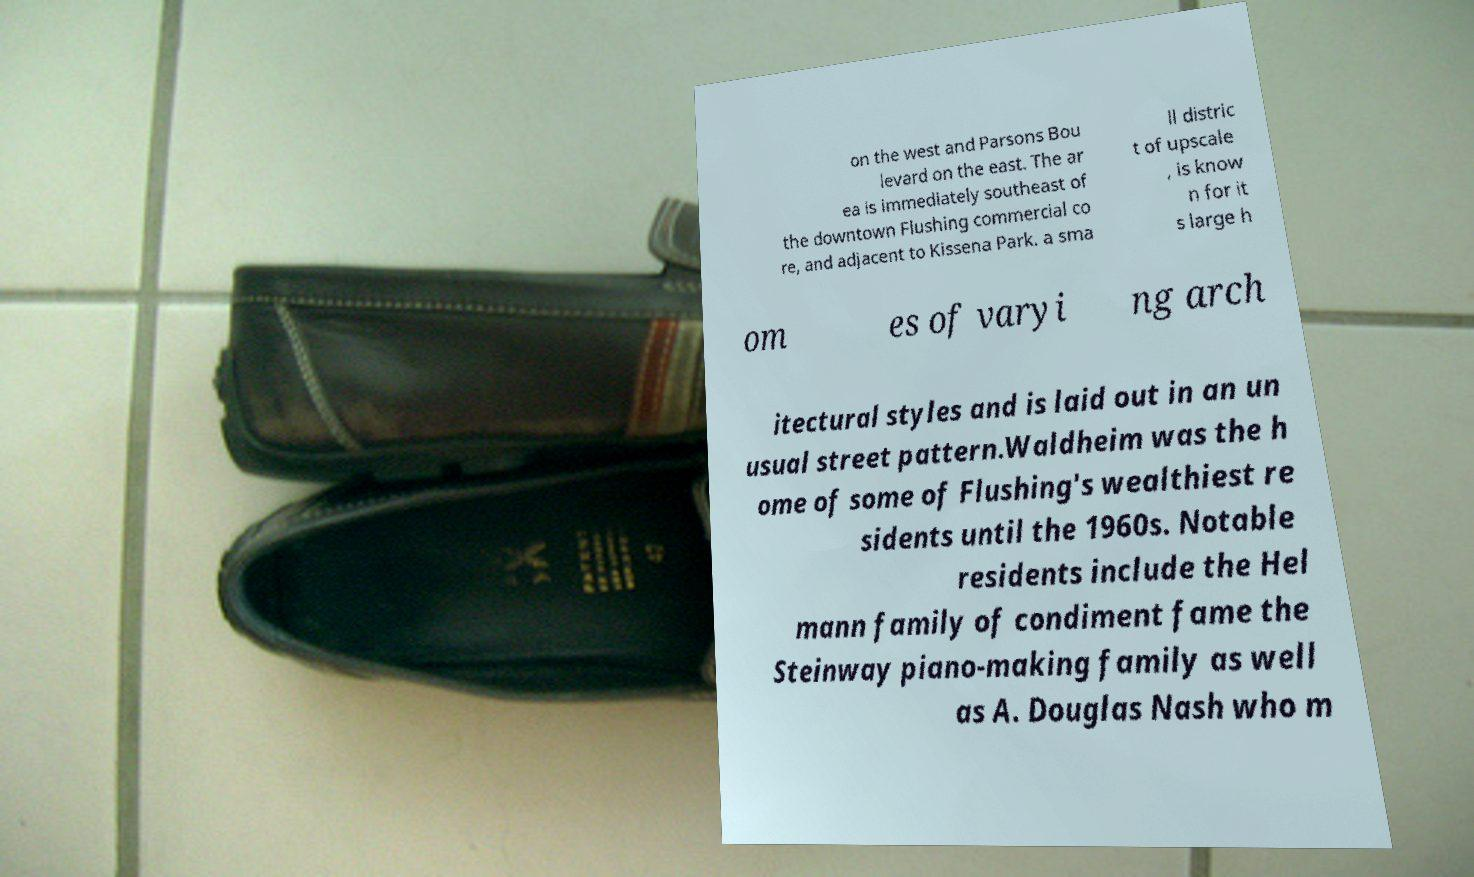Could you assist in decoding the text presented in this image and type it out clearly? on the west and Parsons Bou levard on the east. The ar ea is immediately southeast of the downtown Flushing commercial co re, and adjacent to Kissena Park. a sma ll distric t of upscale , is know n for it s large h om es of varyi ng arch itectural styles and is laid out in an un usual street pattern.Waldheim was the h ome of some of Flushing's wealthiest re sidents until the 1960s. Notable residents include the Hel mann family of condiment fame the Steinway piano-making family as well as A. Douglas Nash who m 